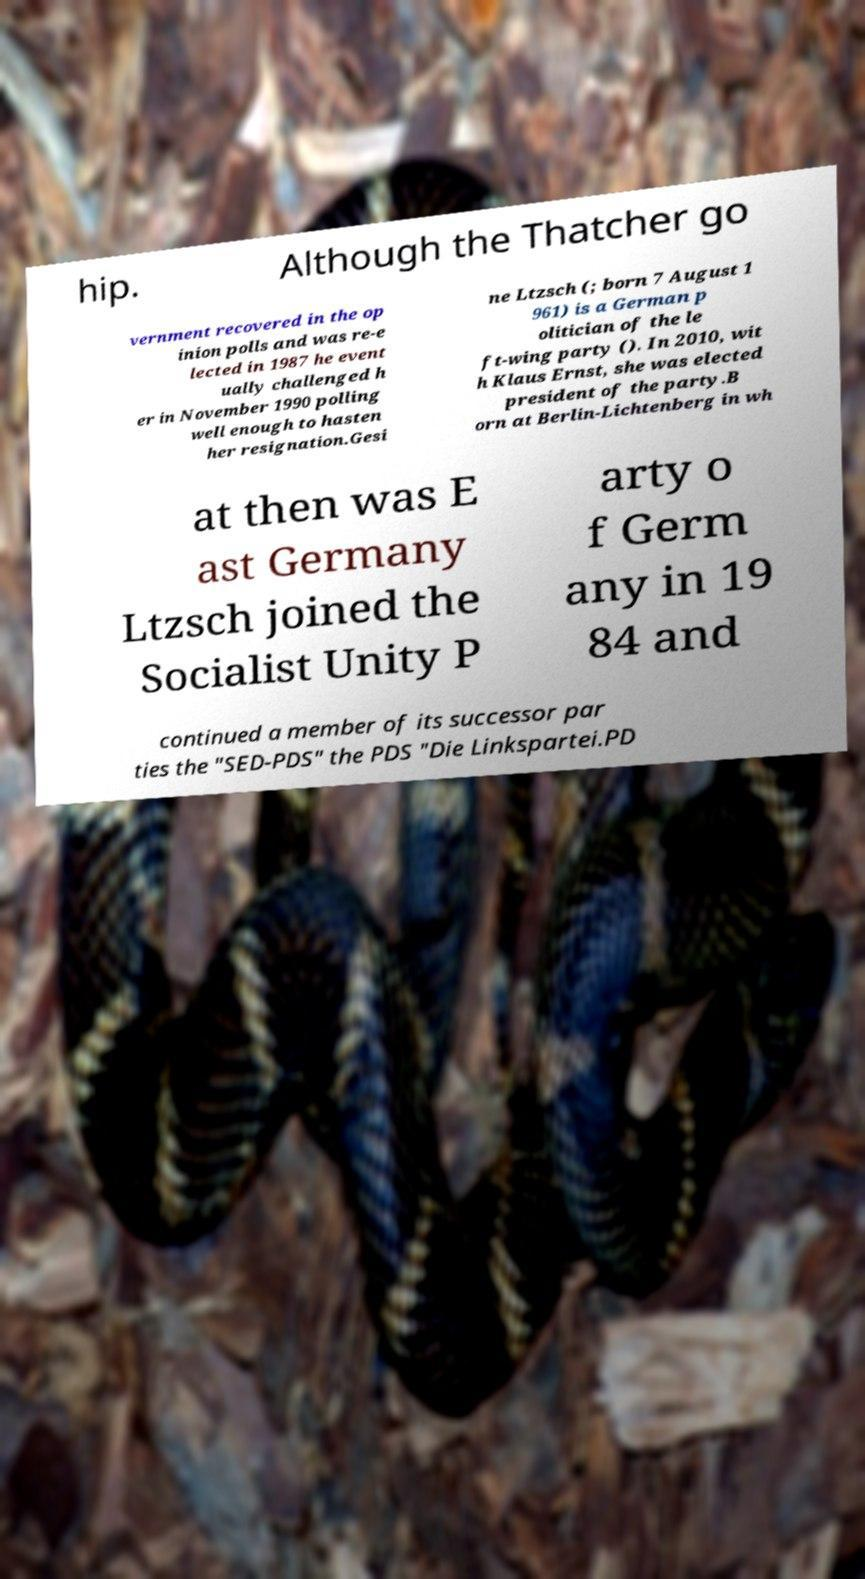Can you accurately transcribe the text from the provided image for me? hip. Although the Thatcher go vernment recovered in the op inion polls and was re-e lected in 1987 he event ually challenged h er in November 1990 polling well enough to hasten her resignation.Gesi ne Ltzsch (; born 7 August 1 961) is a German p olitician of the le ft-wing party (). In 2010, wit h Klaus Ernst, she was elected president of the party.B orn at Berlin-Lichtenberg in wh at then was E ast Germany Ltzsch joined the Socialist Unity P arty o f Germ any in 19 84 and continued a member of its successor par ties the "SED-PDS" the PDS "Die Linkspartei.PD 